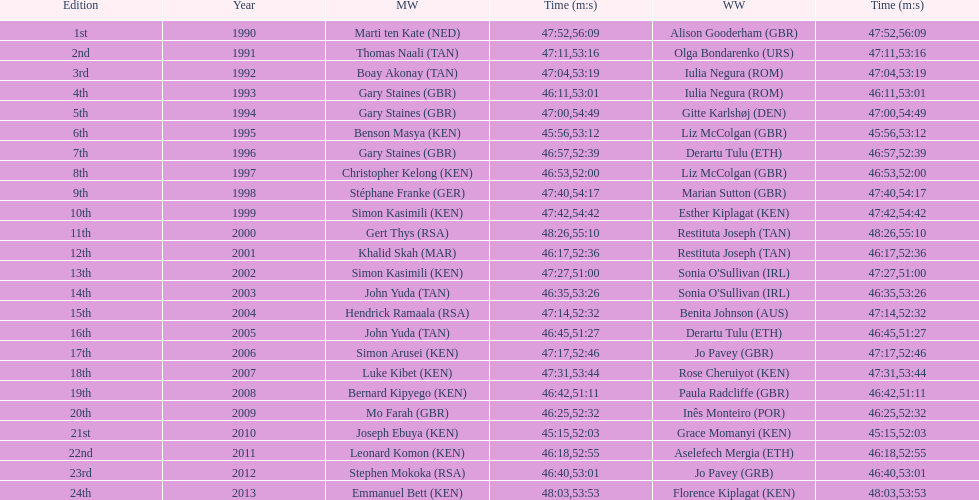Home many times did a single country win both the men's and women's bupa great south run? 4. 